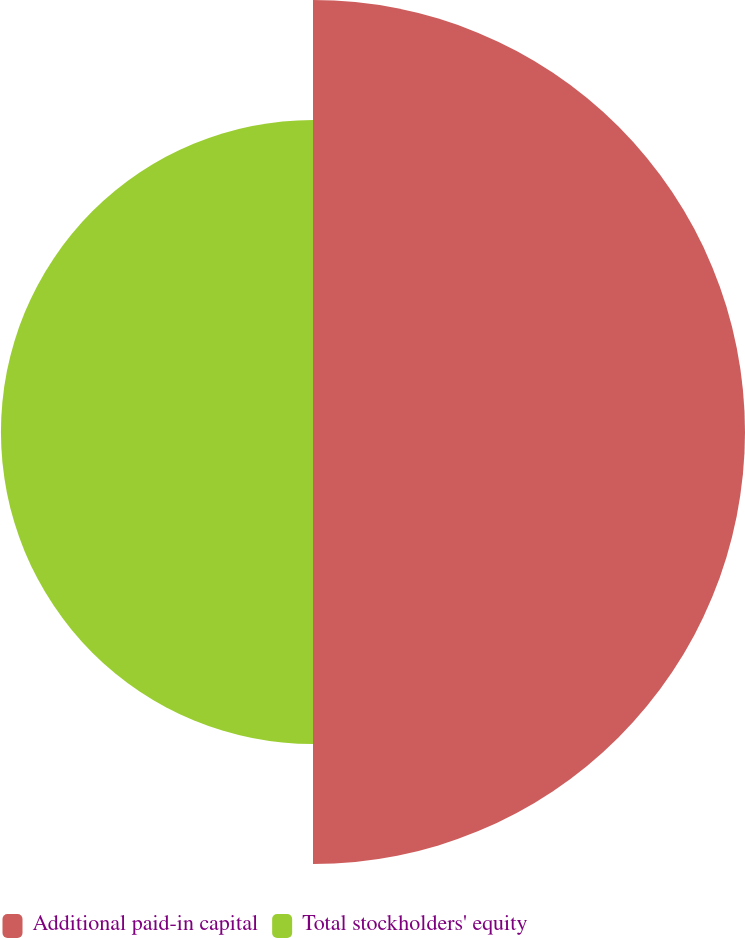Convert chart to OTSL. <chart><loc_0><loc_0><loc_500><loc_500><pie_chart><fcel>Additional paid-in capital<fcel>Total stockholders' equity<nl><fcel>58.06%<fcel>41.94%<nl></chart> 